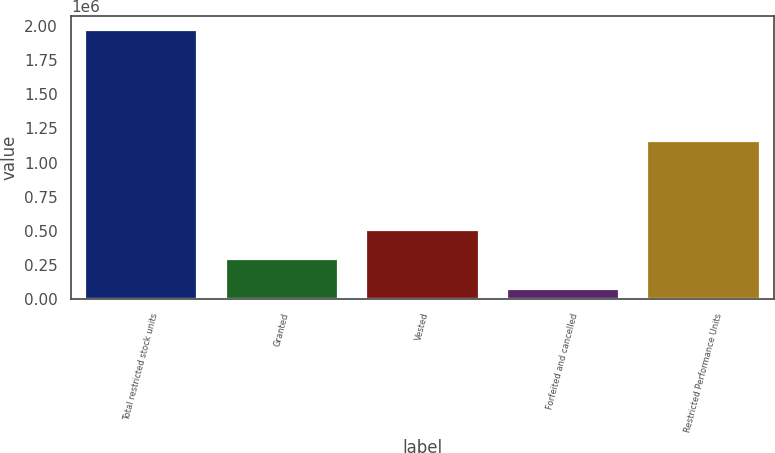Convert chart. <chart><loc_0><loc_0><loc_500><loc_500><bar_chart><fcel>Total restricted stock units<fcel>Granted<fcel>Vested<fcel>Forfeited and cancelled<fcel>Restricted Performance Units<nl><fcel>1.97594e+06<fcel>289428<fcel>506190<fcel>72666<fcel>1.15594e+06<nl></chart> 